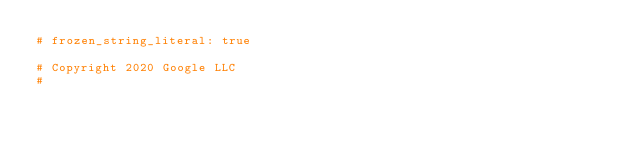Convert code to text. <code><loc_0><loc_0><loc_500><loc_500><_Ruby_># frozen_string_literal: true

# Copyright 2020 Google LLC
#</code> 